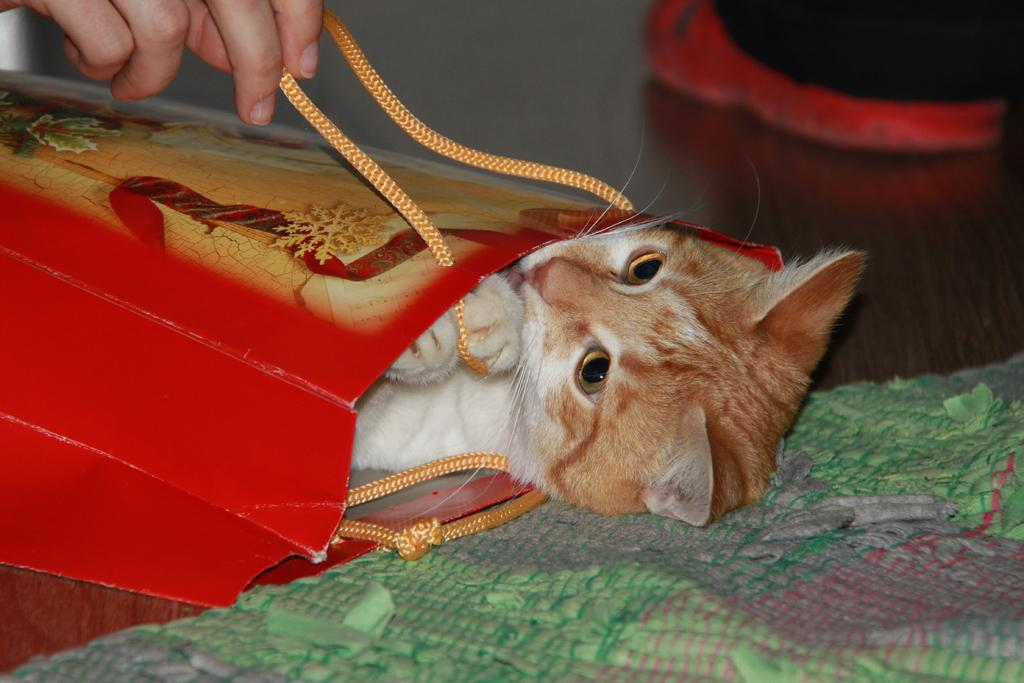What is inside the bag that is visible in the image? There is a cat in the bag. Where is the bag located in the image? The bag is on a table. What can be seen in the top left of the image? There is a hand in the top left of the image. How would you describe the background of the image? The background of the image is blurred. How many boys are visible on the floor in the image? There are no boys visible on the floor in the image. What type of leaf can be seen falling from the tree in the image? There is no tree or leaf present in the image. 